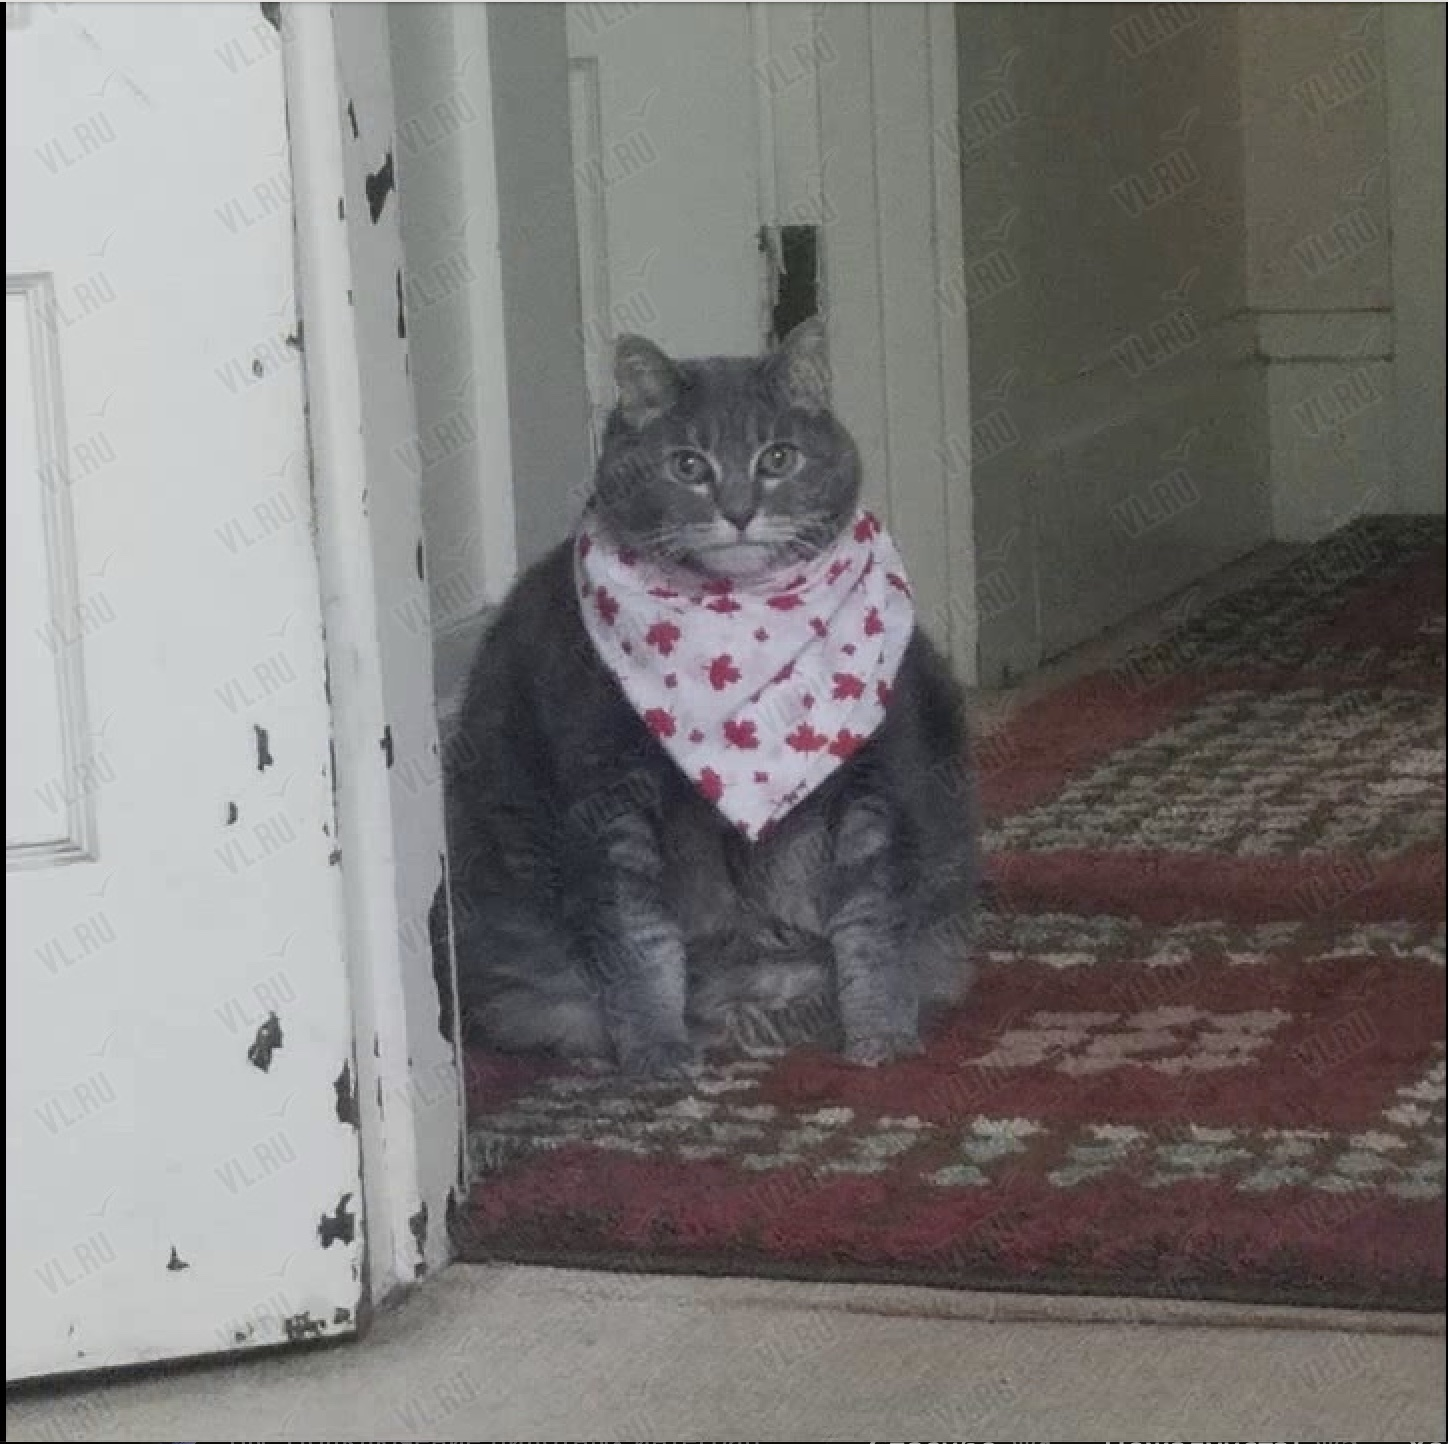Что изображено на фотографии? На фотографии изображен кот, сидящий на ковре в помещении. На нём надет платок с узором в виде красных кленовых листьев. 